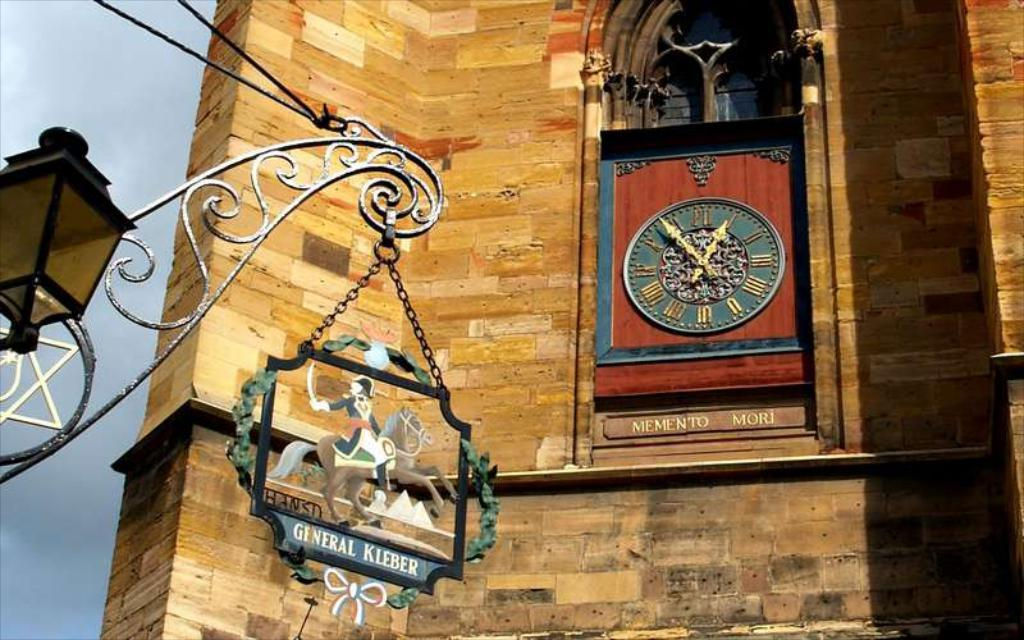<image>
Relay a brief, clear account of the picture shown. A fancy clock on a building reading General Kleber. 